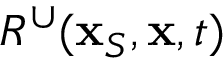Convert formula to latex. <formula><loc_0><loc_0><loc_500><loc_500>R ^ { \cup } ( { x } _ { S } , { x } , t )</formula> 